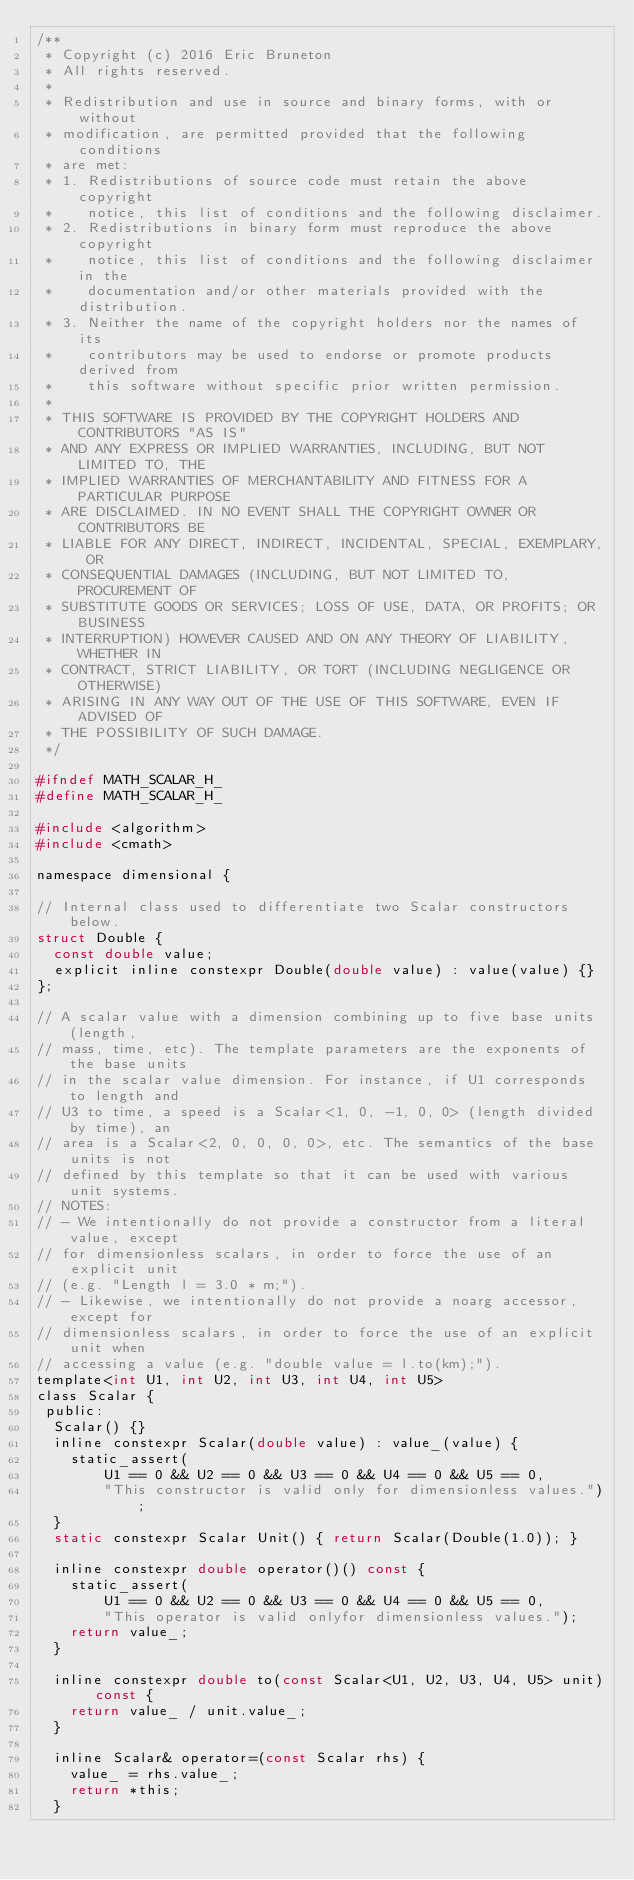Convert code to text. <code><loc_0><loc_0><loc_500><loc_500><_C_>/**
 * Copyright (c) 2016 Eric Bruneton
 * All rights reserved.
 *
 * Redistribution and use in source and binary forms, with or without
 * modification, are permitted provided that the following conditions
 * are met:
 * 1. Redistributions of source code must retain the above copyright
 *    notice, this list of conditions and the following disclaimer.
 * 2. Redistributions in binary form must reproduce the above copyright
 *    notice, this list of conditions and the following disclaimer in the
 *    documentation and/or other materials provided with the distribution.
 * 3. Neither the name of the copyright holders nor the names of its
 *    contributors may be used to endorse or promote products derived from
 *    this software without specific prior written permission.
 *
 * THIS SOFTWARE IS PROVIDED BY THE COPYRIGHT HOLDERS AND CONTRIBUTORS "AS IS"
 * AND ANY EXPRESS OR IMPLIED WARRANTIES, INCLUDING, BUT NOT LIMITED TO, THE
 * IMPLIED WARRANTIES OF MERCHANTABILITY AND FITNESS FOR A PARTICULAR PURPOSE
 * ARE DISCLAIMED. IN NO EVENT SHALL THE COPYRIGHT OWNER OR CONTRIBUTORS BE
 * LIABLE FOR ANY DIRECT, INDIRECT, INCIDENTAL, SPECIAL, EXEMPLARY, OR
 * CONSEQUENTIAL DAMAGES (INCLUDING, BUT NOT LIMITED TO, PROCUREMENT OF
 * SUBSTITUTE GOODS OR SERVICES; LOSS OF USE, DATA, OR PROFITS; OR BUSINESS
 * INTERRUPTION) HOWEVER CAUSED AND ON ANY THEORY OF LIABILITY, WHETHER IN
 * CONTRACT, STRICT LIABILITY, OR TORT (INCLUDING NEGLIGENCE OR OTHERWISE)
 * ARISING IN ANY WAY OUT OF THE USE OF THIS SOFTWARE, EVEN IF ADVISED OF
 * THE POSSIBILITY OF SUCH DAMAGE.
 */

#ifndef MATH_SCALAR_H_
#define MATH_SCALAR_H_

#include <algorithm>
#include <cmath>

namespace dimensional {

// Internal class used to differentiate two Scalar constructors below.
struct Double {
  const double value;
  explicit inline constexpr Double(double value) : value(value) {}
};

// A scalar value with a dimension combining up to five base units (length,
// mass, time, etc). The template parameters are the exponents of the base units
// in the scalar value dimension. For instance, if U1 corresponds to length and
// U3 to time, a speed is a Scalar<1, 0, -1, 0, 0> (length divided by time), an
// area is a Scalar<2, 0, 0, 0, 0>, etc. The semantics of the base units is not
// defined by this template so that it can be used with various unit systems.
// NOTES:
// - We intentionally do not provide a constructor from a literal value, except
// for dimensionless scalars, in order to force the use of an explicit unit
// (e.g. "Length l = 3.0 * m;").
// - Likewise, we intentionally do not provide a noarg accessor, except for
// dimensionless scalars, in order to force the use of an explicit unit when
// accessing a value (e.g. "double value = l.to(km);").
template<int U1, int U2, int U3, int U4, int U5>
class Scalar {
 public:
  Scalar() {}
  inline constexpr Scalar(double value) : value_(value) {
    static_assert(
        U1 == 0 && U2 == 0 && U3 == 0 && U4 == 0 && U5 == 0,
        "This constructor is valid only for dimensionless values.");
  }
  static constexpr Scalar Unit() { return Scalar(Double(1.0)); }

  inline constexpr double operator()() const {
    static_assert(
        U1 == 0 && U2 == 0 && U3 == 0 && U4 == 0 && U5 == 0,
        "This operator is valid onlyfor dimensionless values.");
    return value_;
  }

  inline constexpr double to(const Scalar<U1, U2, U3, U4, U5> unit) const {
    return value_ / unit.value_;
  }

  inline Scalar& operator=(const Scalar rhs) {
    value_ = rhs.value_;
    return *this;
  }
</code> 